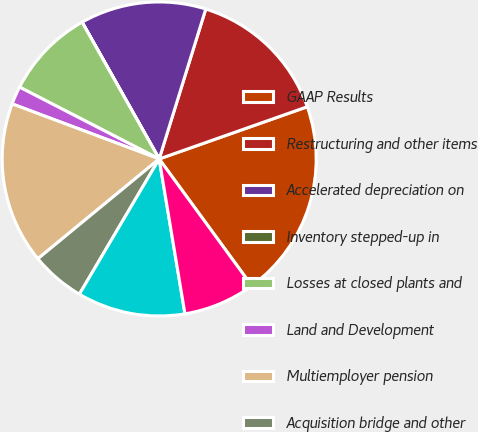<chart> <loc_0><loc_0><loc_500><loc_500><pie_chart><fcel>GAAP Results<fcel>Restructuring and other items<fcel>Accelerated depreciation on<fcel>Inventory stepped-up in<fcel>Losses at closed plants and<fcel>Land and Development<fcel>Multiemployer pension<fcel>Acquisition bridge and other<fcel>Consumer Packaging segment<fcel>Gain on sale of waste services<nl><fcel>20.36%<fcel>14.81%<fcel>12.96%<fcel>0.01%<fcel>9.26%<fcel>1.86%<fcel>16.66%<fcel>5.56%<fcel>11.11%<fcel>7.41%<nl></chart> 